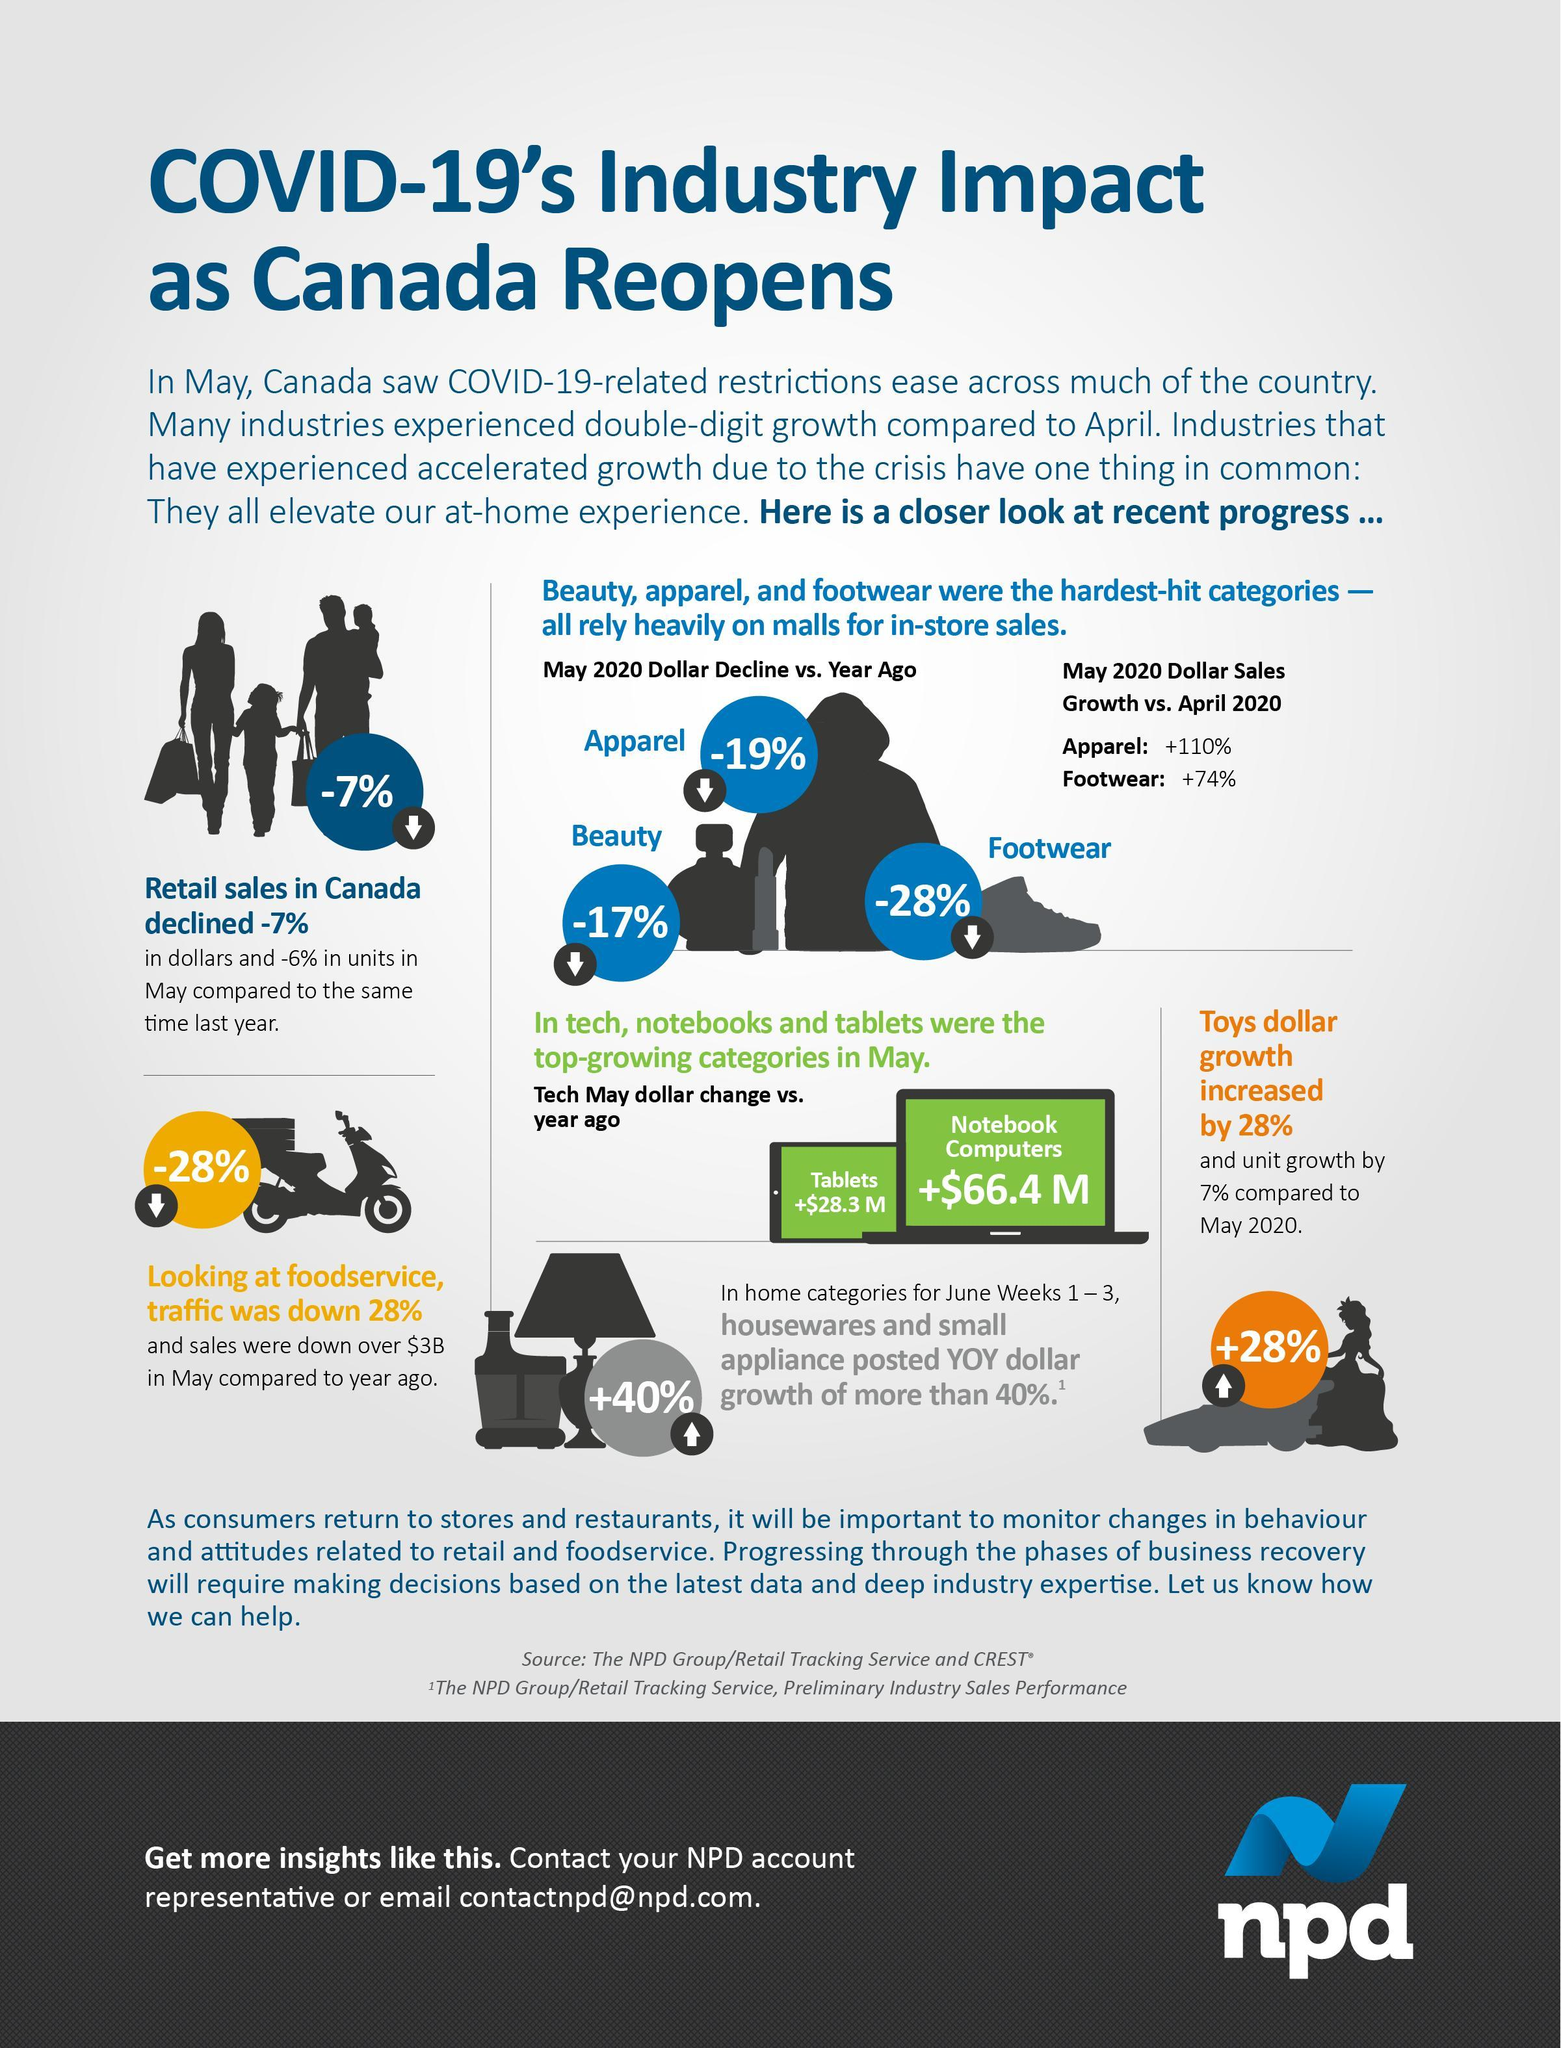Name the consumer goods that were worst affected by Covid-19.
Answer the question with a short phrase. Beauty, Apparel, Footwear Name the technology related items that have shown positive growth. Tablets, Notebook Computers Which is the children specific item that has shown positive growth? Toys 